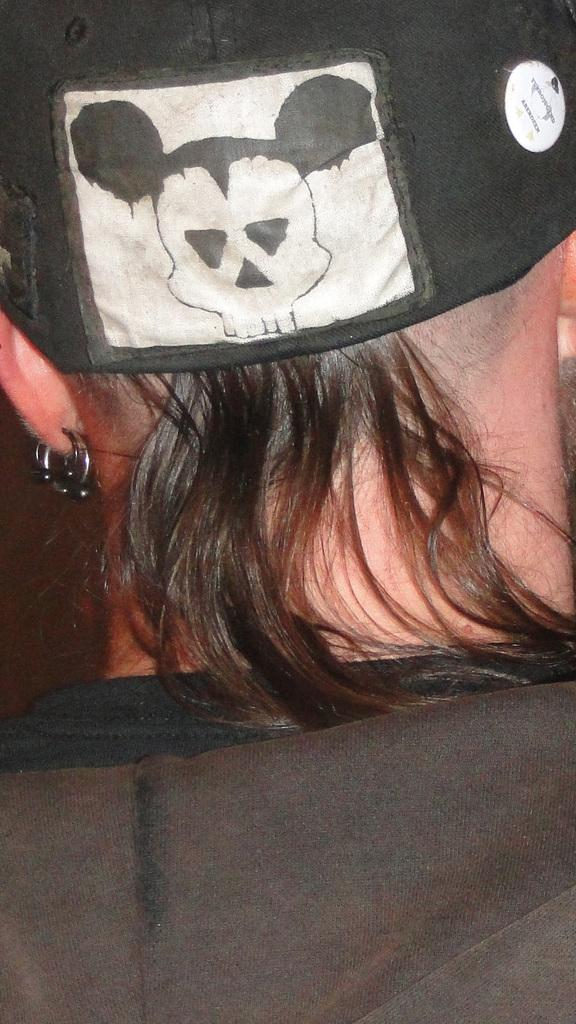Who or what is the main subject in the image? There is a person in the image. What is the person wearing on their head? The person is wearing a cap. Can you describe the appearance of the cap? The cap has black and white colors. What type of cart is being used to serve dinner in the image? There is no cart or dinner present in the image; it only features a person wearing a cap. 